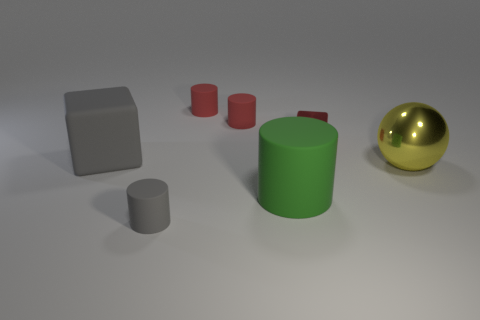There is a rubber block; does it have the same color as the tiny rubber thing that is in front of the yellow thing?
Make the answer very short. Yes. There is a tiny cylinder that is in front of the big matte cylinder; does it have the same color as the rubber block?
Provide a short and direct response. Yes. Are there any small cylinders that have the same color as the large block?
Give a very brief answer. Yes. Is there anything else that has the same shape as the yellow shiny object?
Ensure brevity in your answer.  No. Is the size of the red metallic block the same as the yellow metal ball?
Keep it short and to the point. No. What number of small things are yellow things or cyan metal blocks?
Keep it short and to the point. 0. What number of other things are the same color as the large metal thing?
Your answer should be very brief. 0. Does the block in front of the tiny red metal cube have the same size as the gray rubber object that is on the right side of the large gray rubber cube?
Offer a terse response. No. Is the gray cylinder made of the same material as the block behind the large gray matte object?
Your answer should be compact. No. Is the number of large gray blocks in front of the large rubber cube greater than the number of small red metal cubes in front of the big yellow sphere?
Provide a succinct answer. No. 